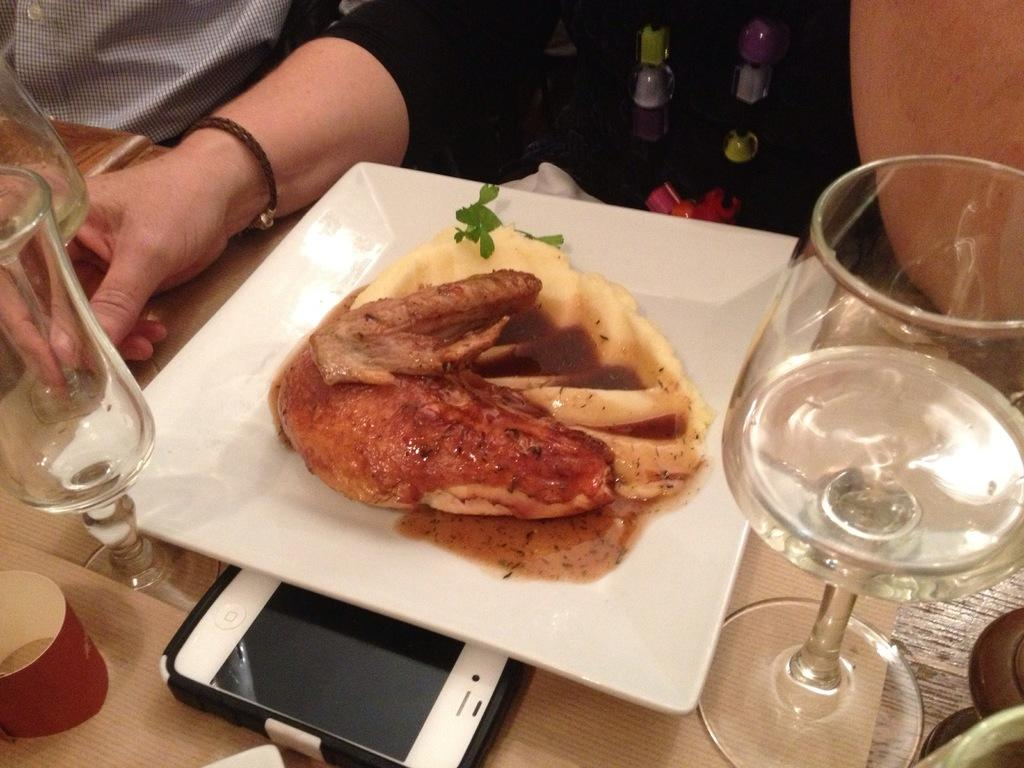What is on the plate in the image? There is a food item in a plate in the image. What else can be seen on the table? There are glasses and a mobile on the table in the image. Can you describe the people in the background of the image? There are people in the background of the image, and one person is holding a glass. What might be the purpose of the mobile on the table? The mobile on the table might be used for communication or entertainment. What type of record can be seen playing on the turntable in the image? There is no turntable or record present in the image. What type of motion can be seen in the image? There is no motion depicted in the image; it is a still photograph. 